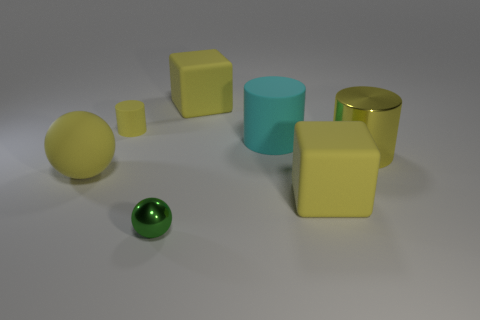Is the tiny cylinder the same color as the matte sphere?
Provide a succinct answer. Yes. There is a object that is in front of the big rubber block that is in front of the small yellow rubber object; what number of big yellow matte blocks are to the left of it?
Keep it short and to the point. 0. How many shiny objects are big yellow cubes or tiny green cylinders?
Offer a terse response. 0. There is a sphere to the right of the tiny object that is behind the cyan thing; how big is it?
Keep it short and to the point. Small. There is a tiny thing behind the big rubber ball; is it the same color as the big rubber cube that is in front of the big metal object?
Your response must be concise. Yes. What color is the thing that is both behind the yellow rubber sphere and left of the green ball?
Give a very brief answer. Yellow. Do the green ball and the big yellow cylinder have the same material?
Give a very brief answer. Yes. What number of tiny objects are green objects or purple shiny cubes?
Offer a terse response. 1. What is the color of the thing that is made of the same material as the small green sphere?
Keep it short and to the point. Yellow. What color is the tiny object that is in front of the big yellow metal cylinder?
Your response must be concise. Green. 